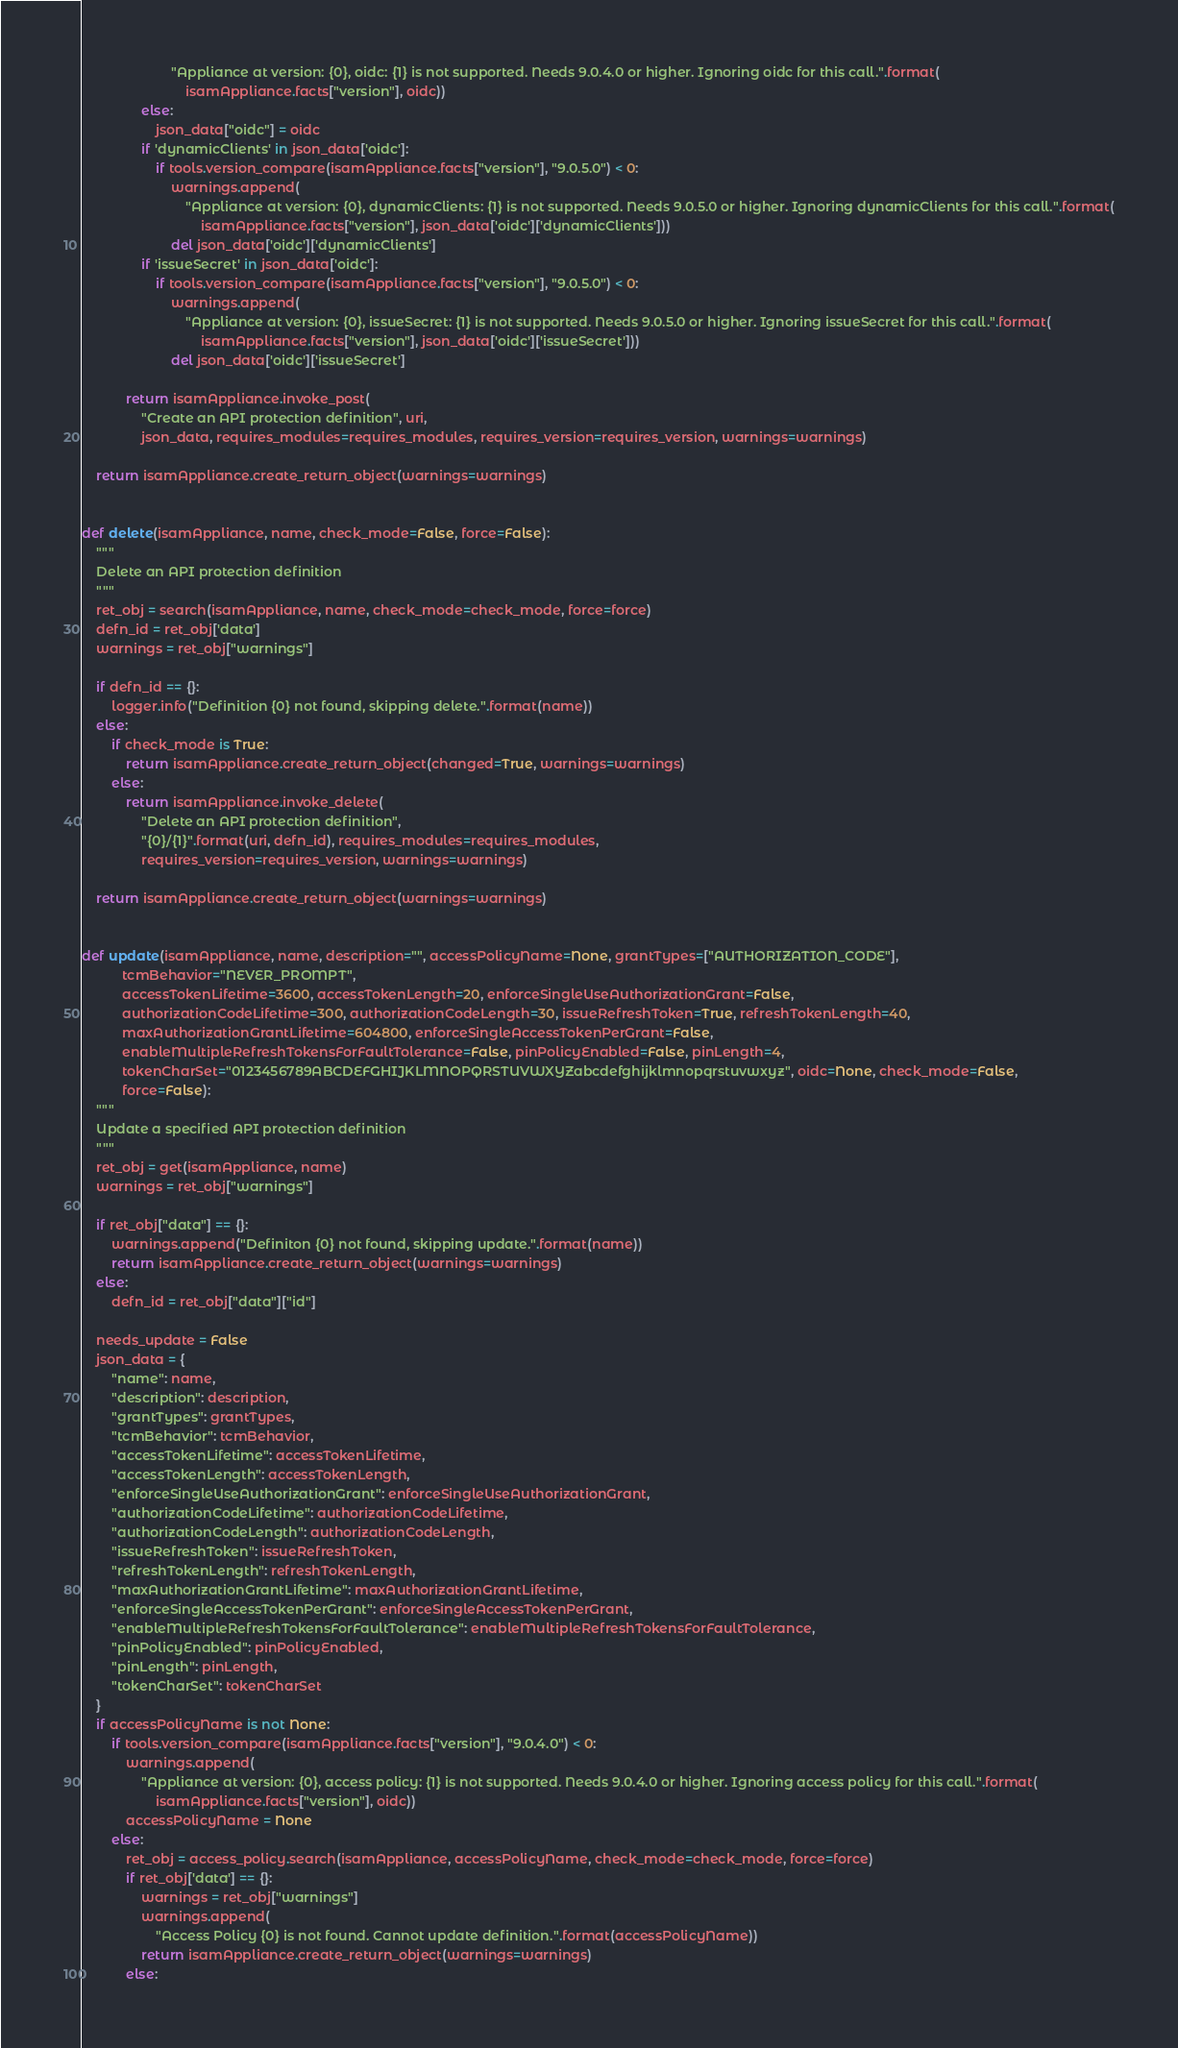Convert code to text. <code><loc_0><loc_0><loc_500><loc_500><_Python_>                        "Appliance at version: {0}, oidc: {1} is not supported. Needs 9.0.4.0 or higher. Ignoring oidc for this call.".format(
                            isamAppliance.facts["version"], oidc))
                else:
                    json_data["oidc"] = oidc
                if 'dynamicClients' in json_data['oidc']:
                    if tools.version_compare(isamAppliance.facts["version"], "9.0.5.0") < 0:
                        warnings.append(
                            "Appliance at version: {0}, dynamicClients: {1} is not supported. Needs 9.0.5.0 or higher. Ignoring dynamicClients for this call.".format(
                                isamAppliance.facts["version"], json_data['oidc']['dynamicClients']))
                        del json_data['oidc']['dynamicClients']
                if 'issueSecret' in json_data['oidc']:
                    if tools.version_compare(isamAppliance.facts["version"], "9.0.5.0") < 0:
                        warnings.append(
                            "Appliance at version: {0}, issueSecret: {1} is not supported. Needs 9.0.5.0 or higher. Ignoring issueSecret for this call.".format(
                                isamAppliance.facts["version"], json_data['oidc']['issueSecret']))
                        del json_data['oidc']['issueSecret']

            return isamAppliance.invoke_post(
                "Create an API protection definition", uri,
                json_data, requires_modules=requires_modules, requires_version=requires_version, warnings=warnings)

    return isamAppliance.create_return_object(warnings=warnings)


def delete(isamAppliance, name, check_mode=False, force=False):
    """
    Delete an API protection definition
    """
    ret_obj = search(isamAppliance, name, check_mode=check_mode, force=force)
    defn_id = ret_obj['data']
    warnings = ret_obj["warnings"]

    if defn_id == {}:
        logger.info("Definition {0} not found, skipping delete.".format(name))
    else:
        if check_mode is True:
            return isamAppliance.create_return_object(changed=True, warnings=warnings)
        else:
            return isamAppliance.invoke_delete(
                "Delete an API protection definition",
                "{0}/{1}".format(uri, defn_id), requires_modules=requires_modules,
                requires_version=requires_version, warnings=warnings)

    return isamAppliance.create_return_object(warnings=warnings)


def update(isamAppliance, name, description="", accessPolicyName=None, grantTypes=["AUTHORIZATION_CODE"],
           tcmBehavior="NEVER_PROMPT",
           accessTokenLifetime=3600, accessTokenLength=20, enforceSingleUseAuthorizationGrant=False,
           authorizationCodeLifetime=300, authorizationCodeLength=30, issueRefreshToken=True, refreshTokenLength=40,
           maxAuthorizationGrantLifetime=604800, enforceSingleAccessTokenPerGrant=False,
           enableMultipleRefreshTokensForFaultTolerance=False, pinPolicyEnabled=False, pinLength=4,
           tokenCharSet="0123456789ABCDEFGHIJKLMNOPQRSTUVWXYZabcdefghijklmnopqrstuvwxyz", oidc=None, check_mode=False,
           force=False):
    """
    Update a specified API protection definition
    """
    ret_obj = get(isamAppliance, name)
    warnings = ret_obj["warnings"]

    if ret_obj["data"] == {}:
        warnings.append("Definiton {0} not found, skipping update.".format(name))
        return isamAppliance.create_return_object(warnings=warnings)
    else:
        defn_id = ret_obj["data"]["id"]

    needs_update = False
    json_data = {
        "name": name,
        "description": description,
        "grantTypes": grantTypes,
        "tcmBehavior": tcmBehavior,
        "accessTokenLifetime": accessTokenLifetime,
        "accessTokenLength": accessTokenLength,
        "enforceSingleUseAuthorizationGrant": enforceSingleUseAuthorizationGrant,
        "authorizationCodeLifetime": authorizationCodeLifetime,
        "authorizationCodeLength": authorizationCodeLength,
        "issueRefreshToken": issueRefreshToken,
        "refreshTokenLength": refreshTokenLength,
        "maxAuthorizationGrantLifetime": maxAuthorizationGrantLifetime,
        "enforceSingleAccessTokenPerGrant": enforceSingleAccessTokenPerGrant,
        "enableMultipleRefreshTokensForFaultTolerance": enableMultipleRefreshTokensForFaultTolerance,
        "pinPolicyEnabled": pinPolicyEnabled,
        "pinLength": pinLength,
        "tokenCharSet": tokenCharSet
    }
    if accessPolicyName is not None:
        if tools.version_compare(isamAppliance.facts["version"], "9.0.4.0") < 0:
            warnings.append(
                "Appliance at version: {0}, access policy: {1} is not supported. Needs 9.0.4.0 or higher. Ignoring access policy for this call.".format(
                    isamAppliance.facts["version"], oidc))
            accessPolicyName = None
        else:
            ret_obj = access_policy.search(isamAppliance, accessPolicyName, check_mode=check_mode, force=force)
            if ret_obj['data'] == {}:
                warnings = ret_obj["warnings"]
                warnings.append(
                    "Access Policy {0} is not found. Cannot update definition.".format(accessPolicyName))
                return isamAppliance.create_return_object(warnings=warnings)
            else:</code> 